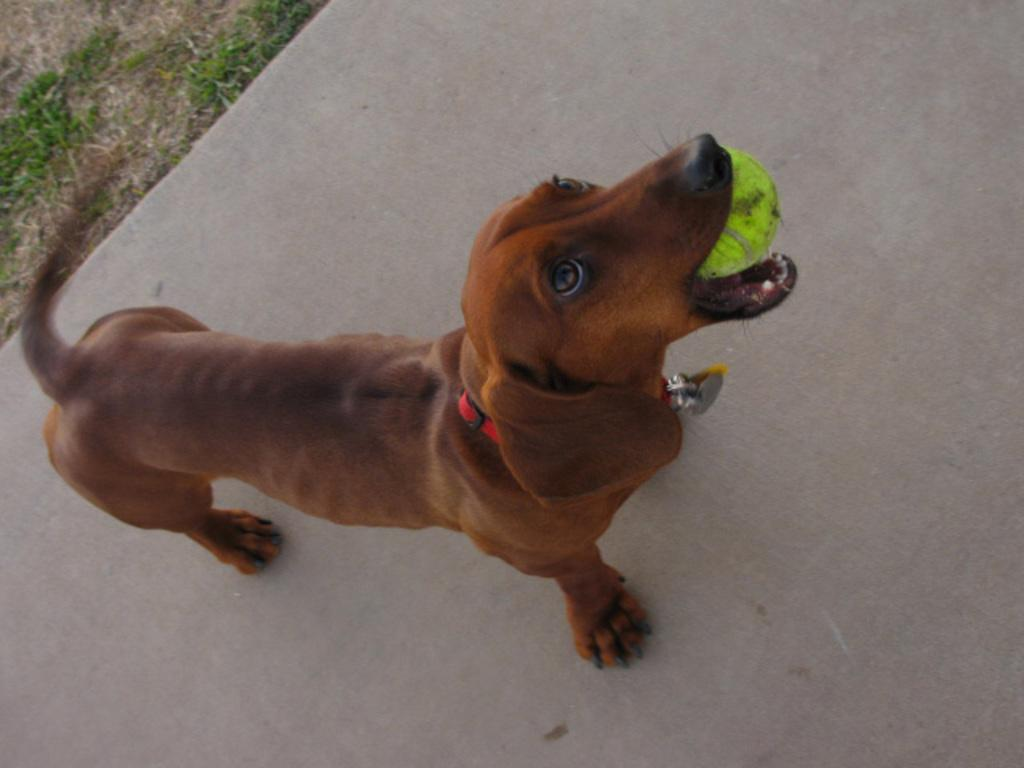What type of animal is in the picture? There is a dog in the picture. What color is the dog? The dog is brown in color. Is there anything around the dog's neck? Yes, the dog has a red color belt around its neck. What is the dog holding in its mouth? The dog is holding a ball in its mouth. What is the ground made of in the picture? There is grass on the ground in the picture. What type of mint can be seen growing in the picture? There is no mint present in the picture; it features a dog holding a ball on a grassy ground. 